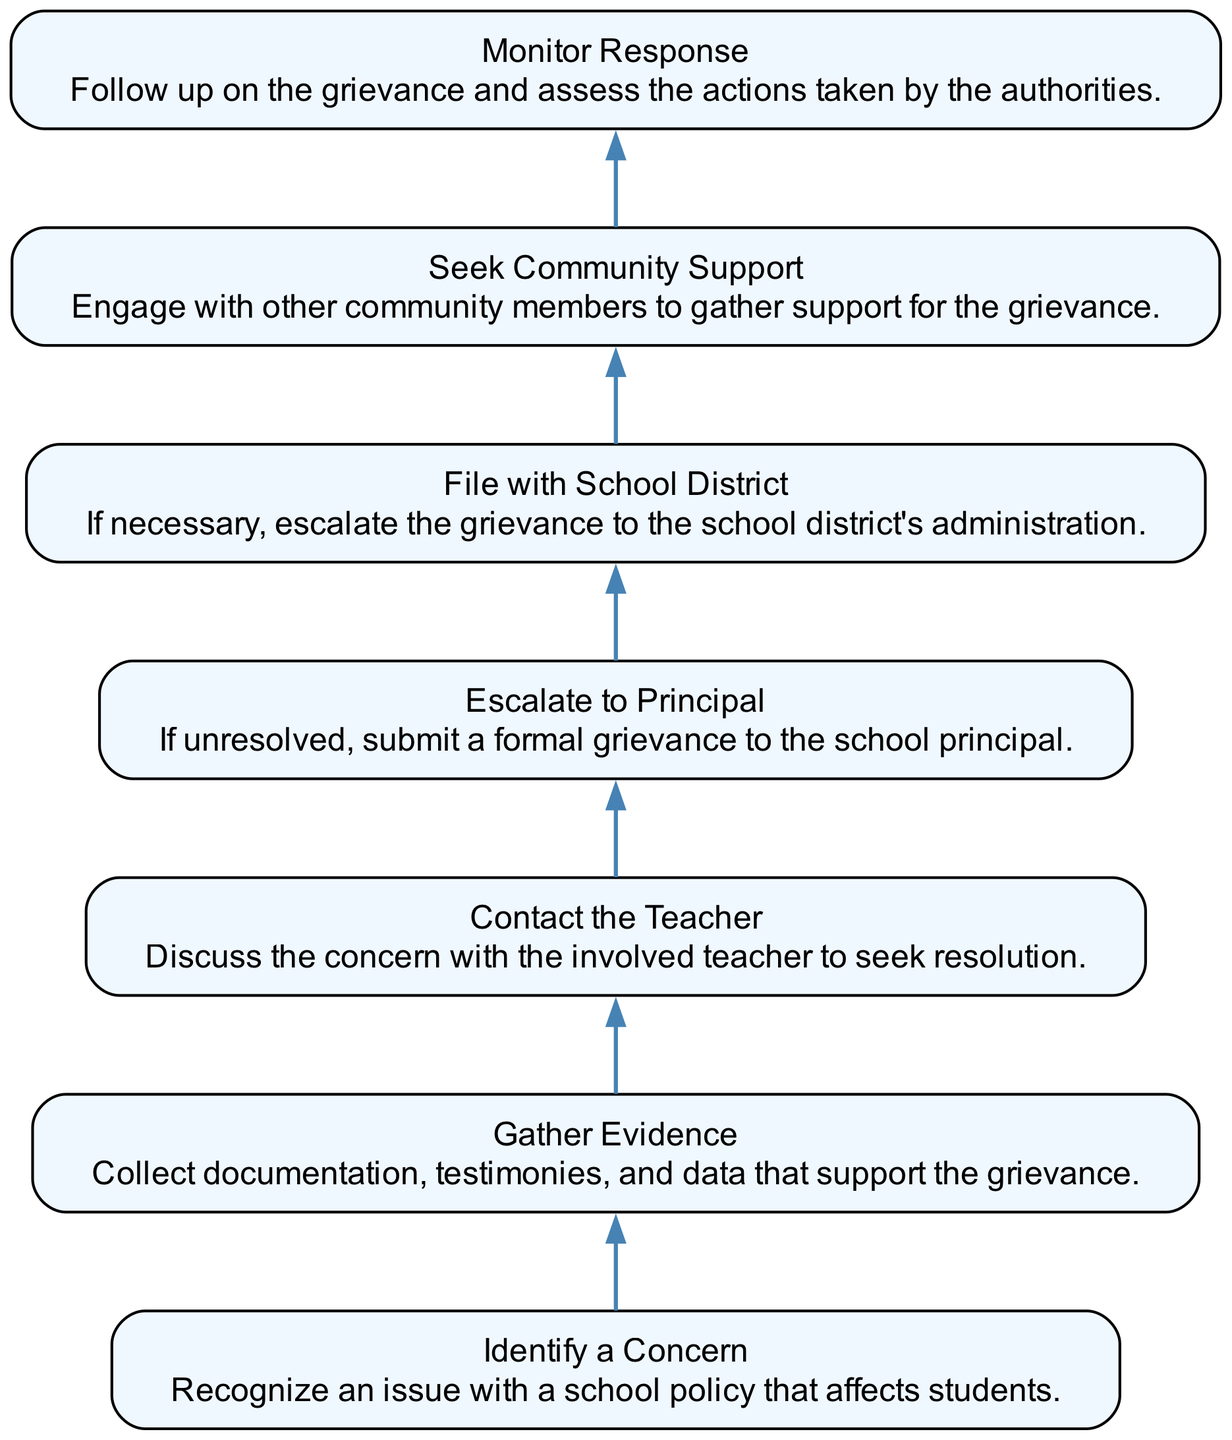What is the first step in the grievance process? The diagram begins with the step labeled "Identify a Concern," which is stated as recognizing an issue with a school policy that affects students.
Answer: Identify a Concern How many total steps are there in the diagram? The diagram features eight distinct nodes representing steps from identification to monitoring responses, thus counting these nodes will give us the total.
Answer: Seven Which step follows "Gather Evidence"? The next step in the sequence after "Gather Evidence" is "Contact the Teacher." This progression is straightforward as each node represents a subsequent action in the grievance process.
Answer: Contact the Teacher What is the fifth step in the process? By counting through the steps formulated in the diagram, moving from "Identify a Concern" sequentially to the fifth node leads us to "File with School District."
Answer: File with School District Who do you escalate to if initial discussions are unsuccessful? If the grievance remains unresolved following the initial steps, the diagram indicates that one should escalate their concerns to the "Principal." This shows the pathway leading from informal to formal grievance management.
Answer: Principal What is the final action listed in the grievance process? The last action in the flow chart is "Monitor Response," which involves following up to observe the actions taken by the authorities in response to the grievance.
Answer: Monitor Response What is the relationship between "Escalate to Principal" and "File with School District"? The relationship shows a directional flow where "Escalate to Principal" serves as a precursor to "File with School District," indicating that if a grievance is not satisfactorily resolved at the principal level, it can be further escalated to district administration.
Answer: Sequential How does "Seek Community Support" relate to the other steps? "Seek Community Support" is a step that can occur concurrently with gathering evidence or prior to approaching the school principal, indicating an effort to build backing for the grievance but does not interrupt the ordered sequence of the main grievance process.
Answer: Concurrent 